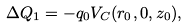<formula> <loc_0><loc_0><loc_500><loc_500>\Delta Q _ { 1 } = - q _ { 0 } V _ { C } ( r _ { 0 } , 0 , z _ { 0 } ) ,</formula> 